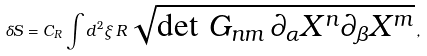Convert formula to latex. <formula><loc_0><loc_0><loc_500><loc_500>\delta S = C _ { R } \int d ^ { 2 } \xi \, R \, \sqrt { \det \, G _ { n m } \, \partial _ { \alpha } X ^ { n } \partial _ { \beta } X ^ { m } } \, ,</formula> 